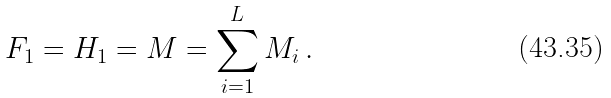Convert formula to latex. <formula><loc_0><loc_0><loc_500><loc_500>F _ { 1 } = H _ { 1 } = M = \sum _ { i = 1 } ^ { L } M _ { i } \, .</formula> 